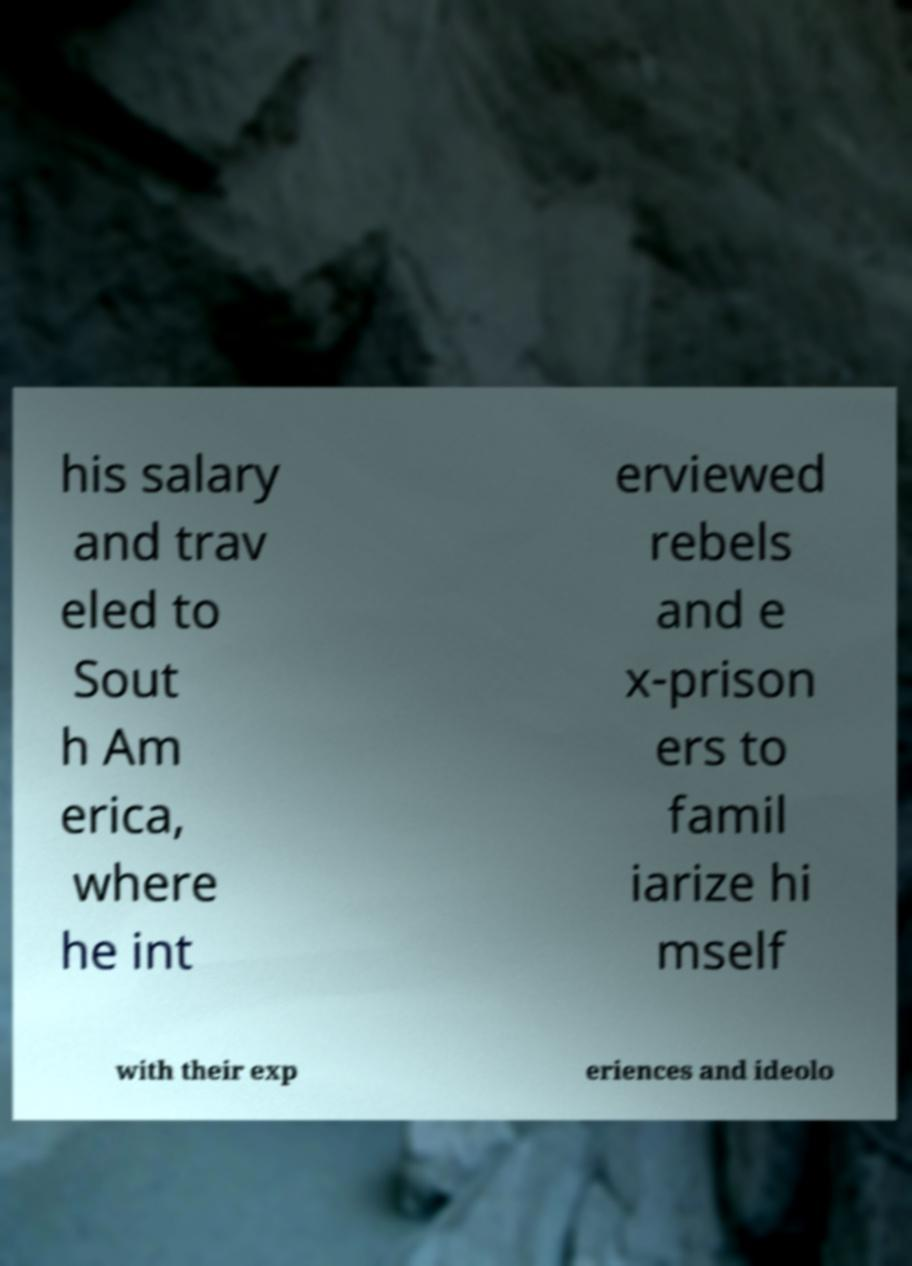There's text embedded in this image that I need extracted. Can you transcribe it verbatim? his salary and trav eled to Sout h Am erica, where he int erviewed rebels and e x-prison ers to famil iarize hi mself with their exp eriences and ideolo 